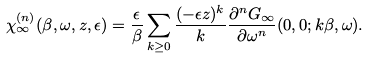<formula> <loc_0><loc_0><loc_500><loc_500>\chi _ { \infty } ^ { ( n ) } ( \beta , \omega , z , \epsilon ) = \frac { \epsilon } { \beta } \sum _ { k \geq 0 } \frac { ( - \epsilon z ) ^ { k } } { k } \frac { \partial ^ { n } G _ { \infty } } { \partial \omega ^ { n } } ( { 0 } , { 0 } ; k \beta , \omega ) .</formula> 